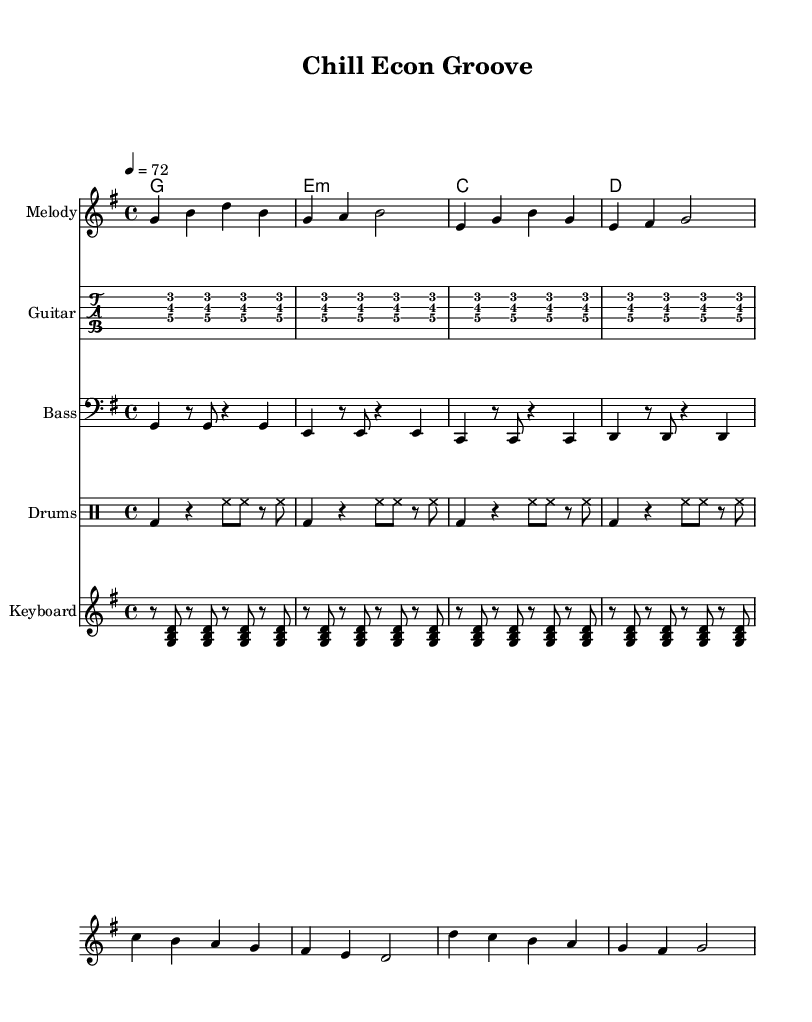What is the key signature of this music? The key signature is G major, which has one sharp (F#). This is indicated at the beginning of the staff.
Answer: G major What is the time signature of this music? The time signature is 4/4, as indicated at the beginning of the score. This means there are four beats in a measure and the quarter note gets one beat.
Answer: 4/4 What is the tempo marked in this music? The tempo is marked as "4 = 72," which signifies that there are 72 quarter note beats per minute. This is typical for a relaxed pace in reggae music.
Answer: 72 How many measures are in the melody section? The melody section contains eight measures, which can be counted by identifying the vertical bar lines that divide the music into measures.
Answer: Eight What type of chords are present in the chord progression? The chords present are G major, E minor, C major, and D major. The progression moves through major and minor chords that are common in reggae music.
Answer: G, E minor, C, D What instruments are included in this arrangement? The arrangement includes the melody, guitar, bass, drums, and keyboard. Each part is written out separately to create a fuller sound, typical for reggae ensembles.
Answer: Melody, Guitar, Bass, Drums, Keyboard What is the rhythmic pattern used in the drum part? The drum part uses a kick drum followed by hi-hat played in eighth notes, which is characteristic of reggae music's emphasis on the offbeat.
Answer: Kick, Hi-hat 